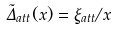<formula> <loc_0><loc_0><loc_500><loc_500>\tilde { \Delta } _ { a t t } ( x ) = \xi _ { a t t } / x</formula> 